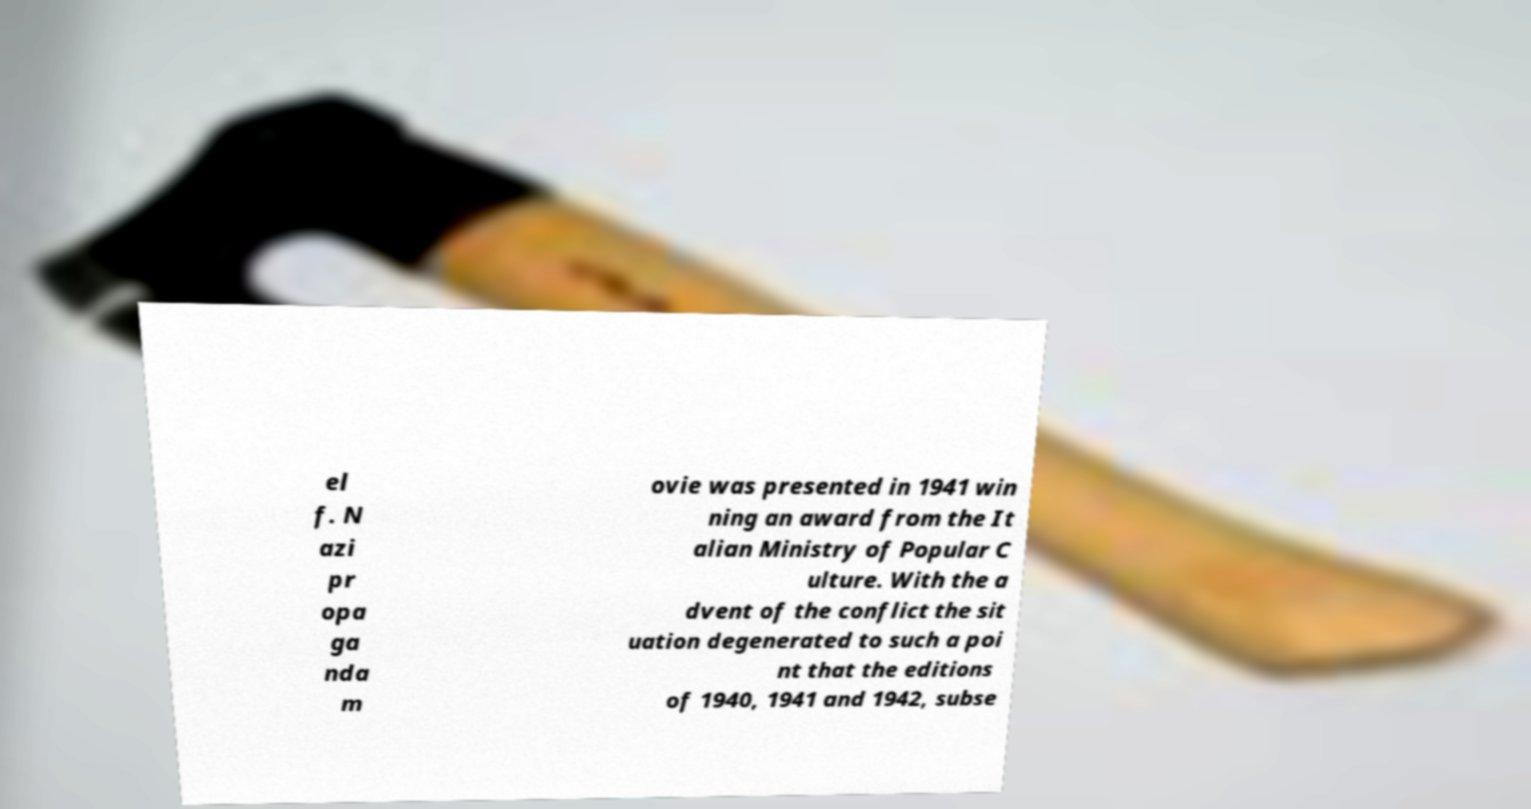Can you read and provide the text displayed in the image?This photo seems to have some interesting text. Can you extract and type it out for me? el f. N azi pr opa ga nda m ovie was presented in 1941 win ning an award from the It alian Ministry of Popular C ulture. With the a dvent of the conflict the sit uation degenerated to such a poi nt that the editions of 1940, 1941 and 1942, subse 